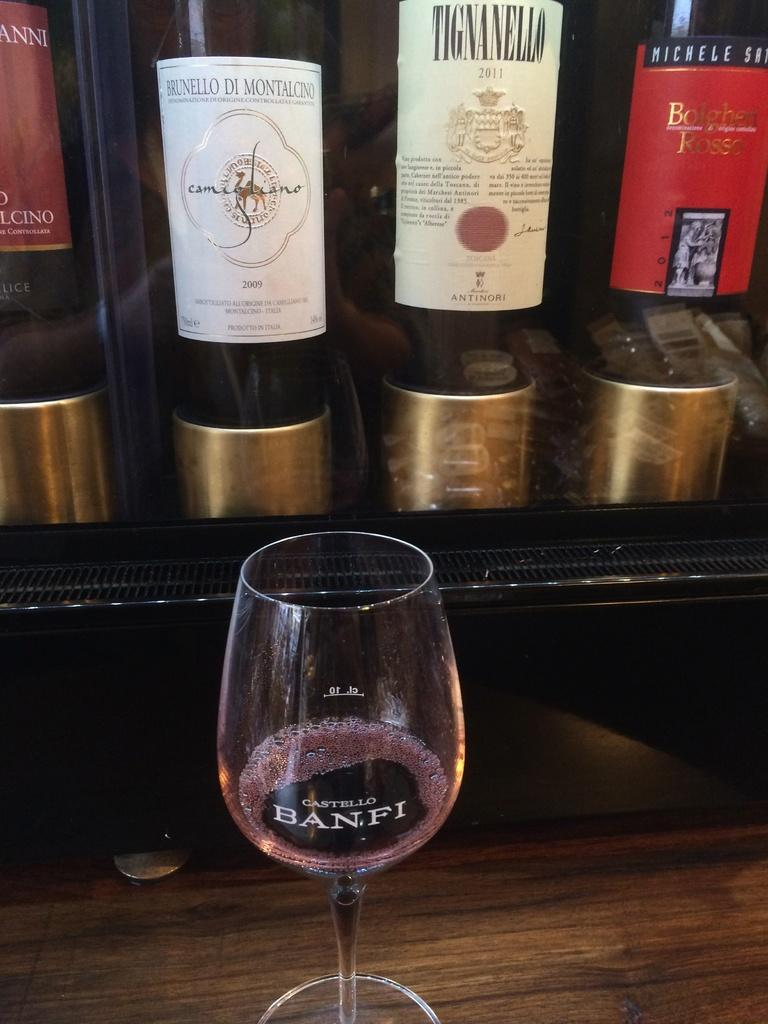Provide a one-sentence caption for the provided image. Bottles of wine sit behind a glass etched with  Castello Banfi. 